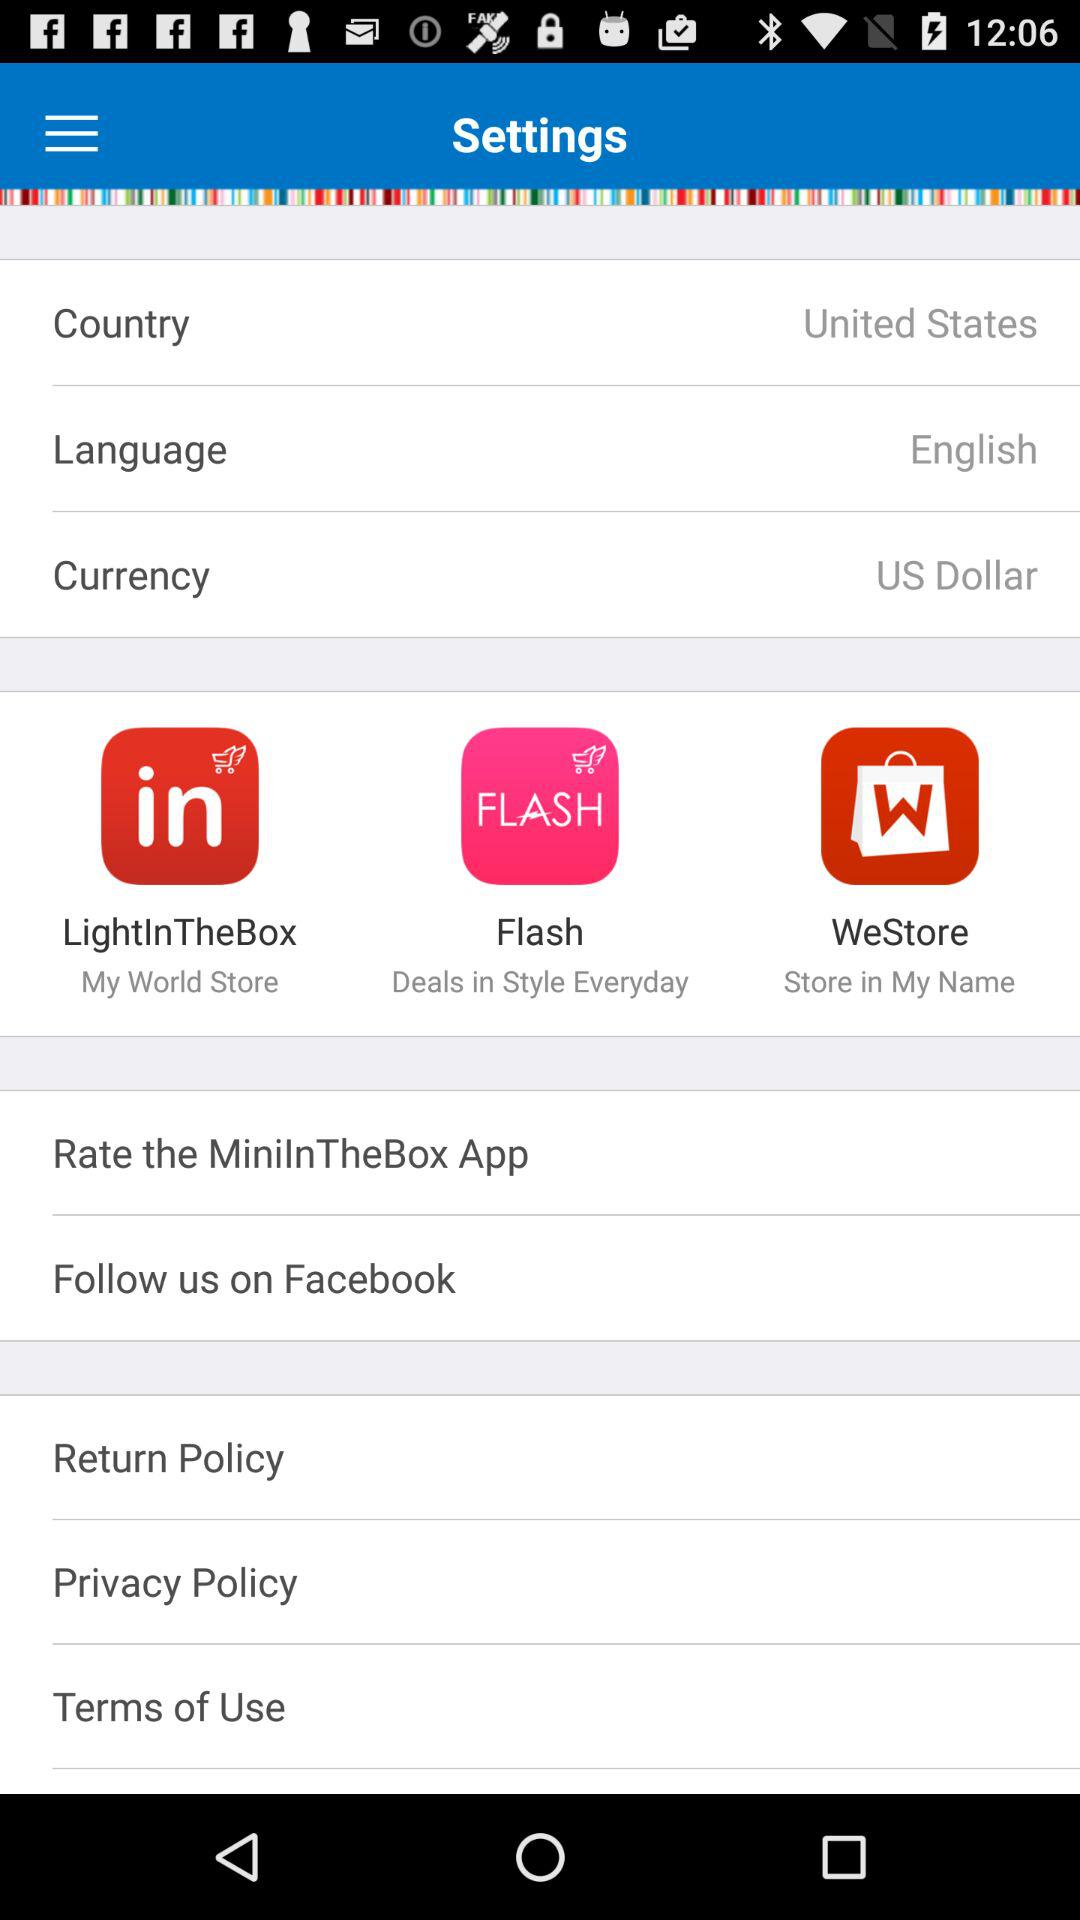How many stars does "MiniInTheBox" have?
When the provided information is insufficient, respond with <no answer>. <no answer> 